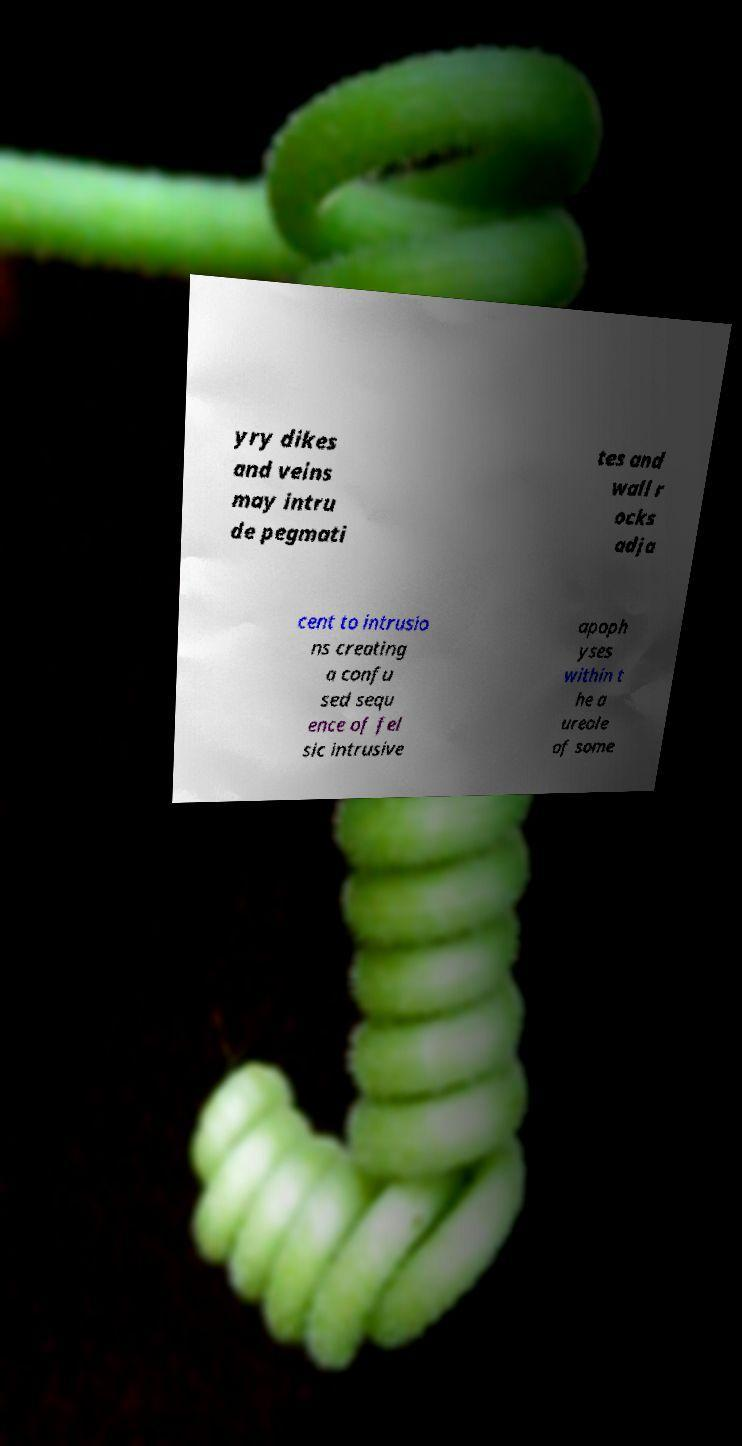Please read and relay the text visible in this image. What does it say? yry dikes and veins may intru de pegmati tes and wall r ocks adja cent to intrusio ns creating a confu sed sequ ence of fel sic intrusive apoph yses within t he a ureole of some 